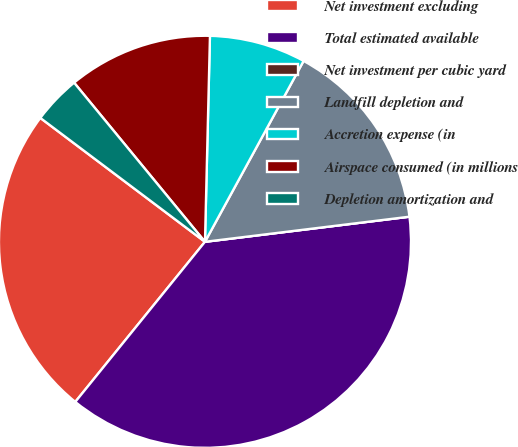<chart> <loc_0><loc_0><loc_500><loc_500><pie_chart><fcel>Net investment excluding<fcel>Total estimated available<fcel>Net investment per cubic yard<fcel>Landfill depletion and<fcel>Accretion expense (in<fcel>Airspace consumed (in millions<fcel>Depletion amortization and<nl><fcel>24.43%<fcel>37.78%<fcel>0.0%<fcel>15.11%<fcel>7.56%<fcel>11.34%<fcel>3.78%<nl></chart> 